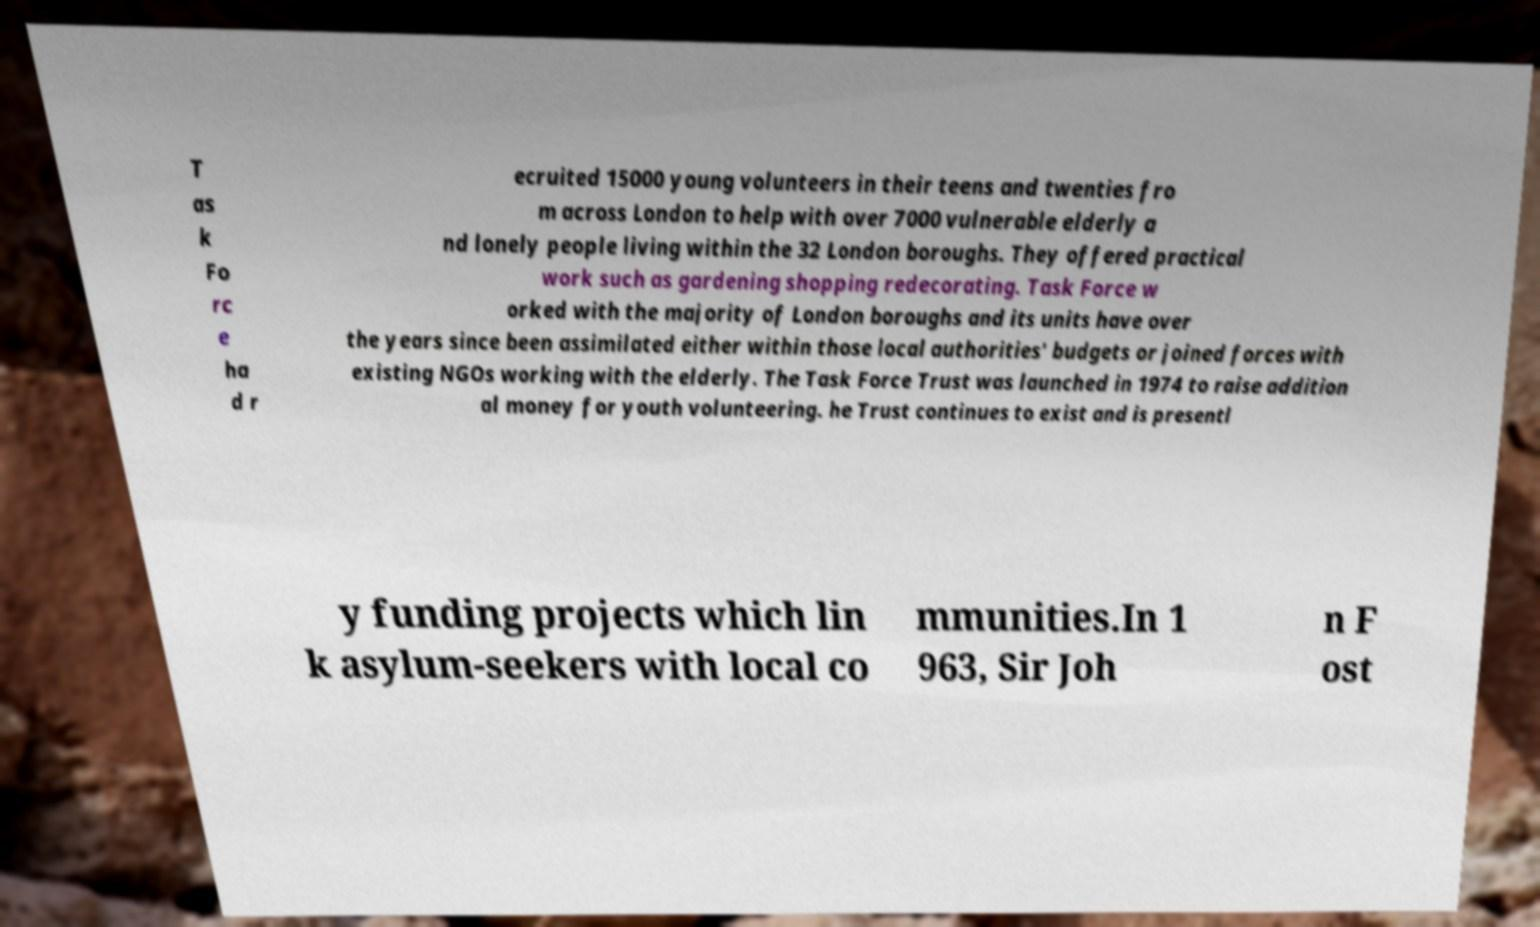There's text embedded in this image that I need extracted. Can you transcribe it verbatim? T as k Fo rc e ha d r ecruited 15000 young volunteers in their teens and twenties fro m across London to help with over 7000 vulnerable elderly a nd lonely people living within the 32 London boroughs. They offered practical work such as gardening shopping redecorating. Task Force w orked with the majority of London boroughs and its units have over the years since been assimilated either within those local authorities' budgets or joined forces with existing NGOs working with the elderly. The Task Force Trust was launched in 1974 to raise addition al money for youth volunteering. he Trust continues to exist and is presentl y funding projects which lin k asylum-seekers with local co mmunities.In 1 963, Sir Joh n F ost 